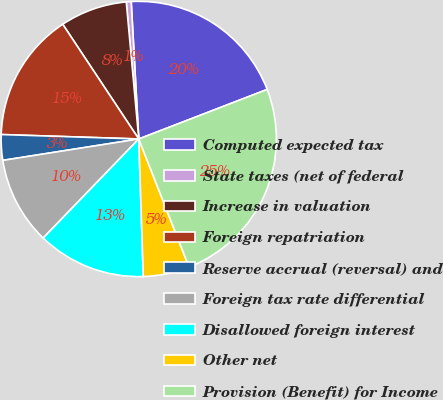Convert chart to OTSL. <chart><loc_0><loc_0><loc_500><loc_500><pie_chart><fcel>Computed expected tax<fcel>State taxes (net of federal<fcel>Increase in valuation<fcel>Foreign repatriation<fcel>Reserve accrual (reversal) and<fcel>Foreign tax rate differential<fcel>Disallowed foreign interest<fcel>Other net<fcel>Provision (Benefit) for Income<nl><fcel>20.02%<fcel>0.57%<fcel>7.87%<fcel>15.17%<fcel>3.0%<fcel>10.3%<fcel>12.74%<fcel>5.43%<fcel>24.91%<nl></chart> 